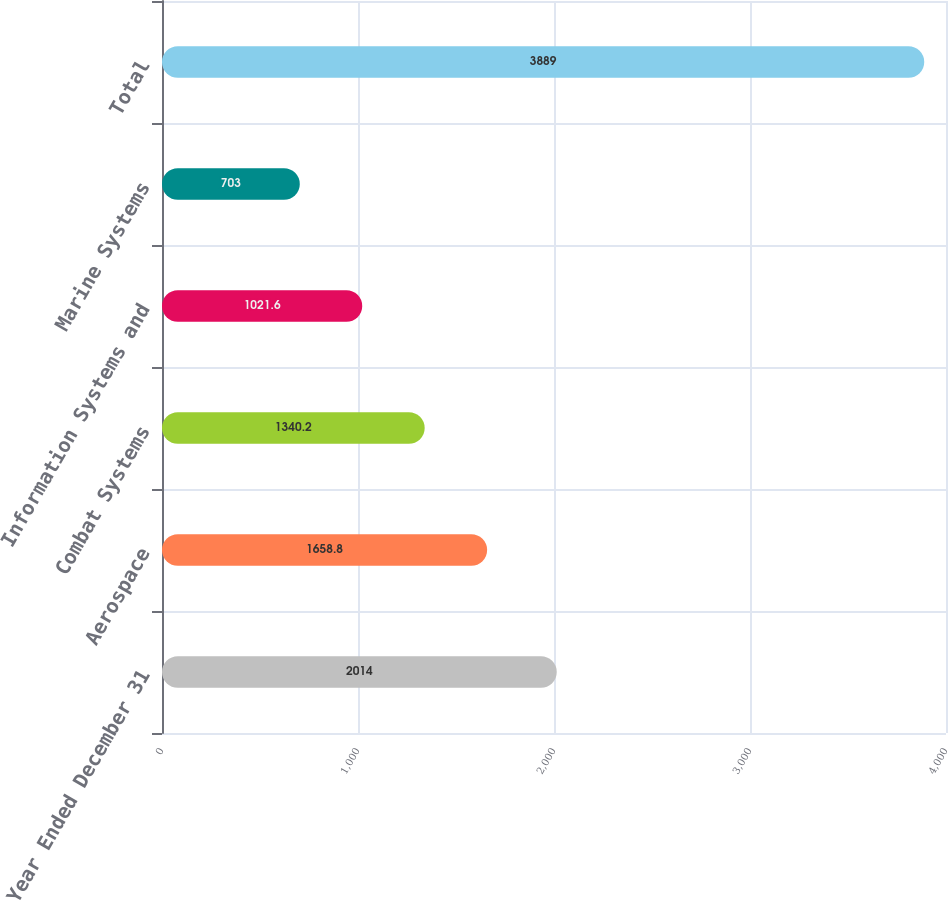Convert chart to OTSL. <chart><loc_0><loc_0><loc_500><loc_500><bar_chart><fcel>Year Ended December 31<fcel>Aerospace<fcel>Combat Systems<fcel>Information Systems and<fcel>Marine Systems<fcel>Total<nl><fcel>2014<fcel>1658.8<fcel>1340.2<fcel>1021.6<fcel>703<fcel>3889<nl></chart> 